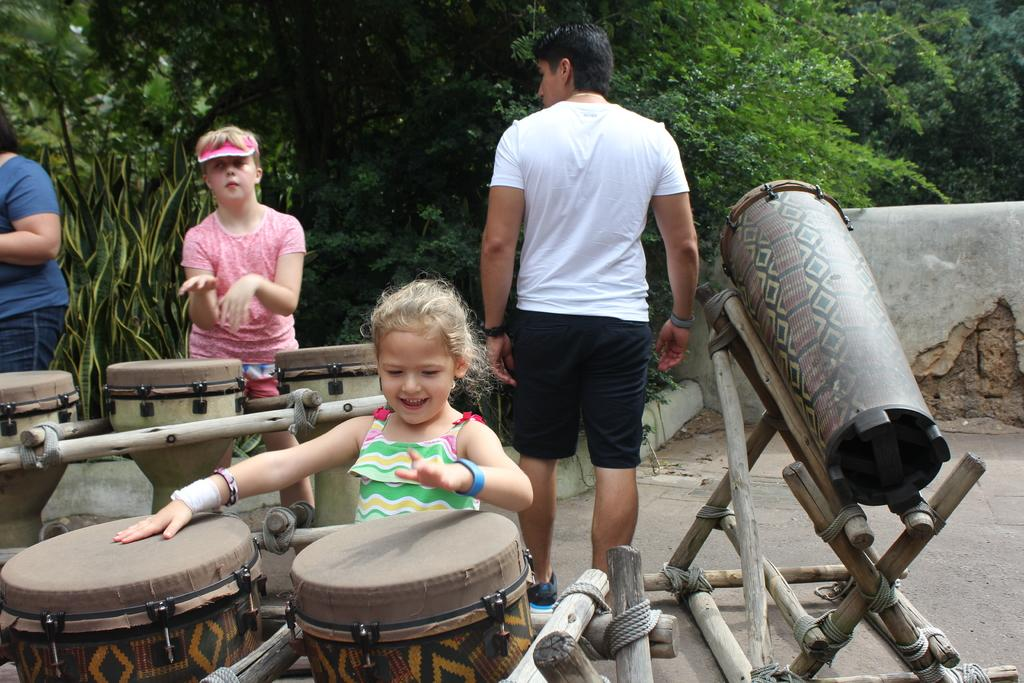Who is the main subject in the image? There is a girl in the image. What is the girl doing in the image? The girl is near the drums. What objects are present in the image besides the girl? There are drums in the image. How many more persons can be seen in the background of the image? There are three more persons in the background of the image. What are the persons in the background doing? The persons in the background are standing. What can be seen in the background of the image besides the persons? There is a wall and trees in the background of the image. What type of flowers can be seen growing on the wall in the image? There are no flowers visible on the wall in the image. 